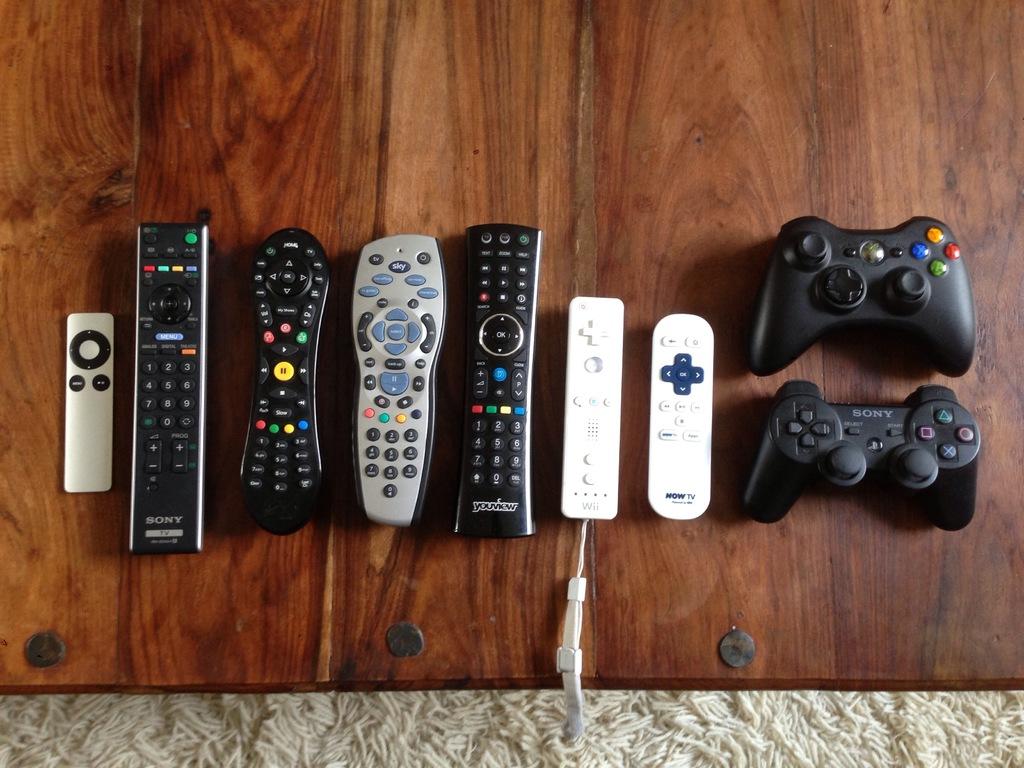What is one of the brands of the remotes seen here?
Offer a very short reply. Sony. 